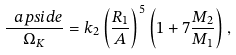Convert formula to latex. <formula><loc_0><loc_0><loc_500><loc_500>\frac { \ a p s i d e } { \Omega _ { K } } = k _ { 2 } \left ( \frac { R _ { 1 } } { A } \right ) ^ { 5 } \left ( { 1 + 7 \frac { M _ { 2 } } { M _ { 1 } } } \right ) ,</formula> 